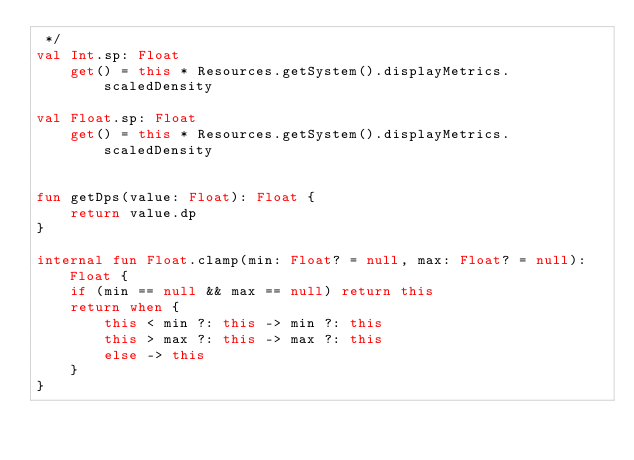Convert code to text. <code><loc_0><loc_0><loc_500><loc_500><_Kotlin_> */
val Int.sp: Float
    get() = this * Resources.getSystem().displayMetrics.scaledDensity

val Float.sp: Float
    get() = this * Resources.getSystem().displayMetrics.scaledDensity


fun getDps(value: Float): Float {
    return value.dp
}

internal fun Float.clamp(min: Float? = null, max: Float? = null): Float {
    if (min == null && max == null) return this
    return when {
        this < min ?: this -> min ?: this
        this > max ?: this -> max ?: this
        else -> this
    }
}</code> 